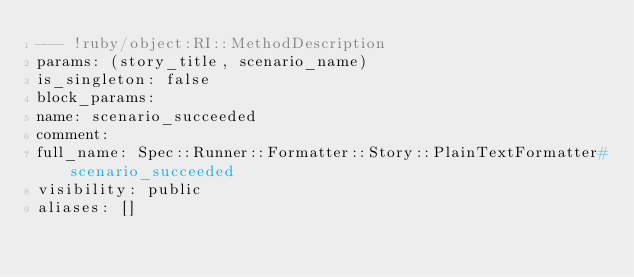<code> <loc_0><loc_0><loc_500><loc_500><_YAML_>--- !ruby/object:RI::MethodDescription
params: (story_title, scenario_name)
is_singleton: false
block_params: 
name: scenario_succeeded
comment: 
full_name: Spec::Runner::Formatter::Story::PlainTextFormatter#scenario_succeeded
visibility: public
aliases: []
</code> 